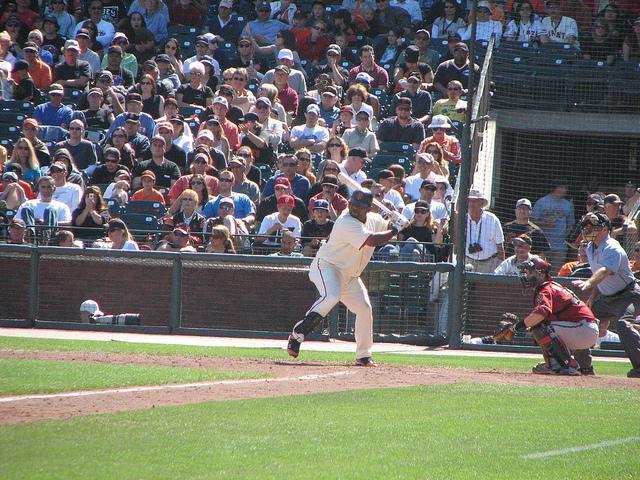How many people can you see?
Give a very brief answer. 4. How many bears in the picture?
Give a very brief answer. 0. 